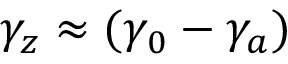<formula> <loc_0><loc_0><loc_500><loc_500>\gamma _ { z } \approx ( \gamma _ { 0 } - \gamma _ { a } )</formula> 